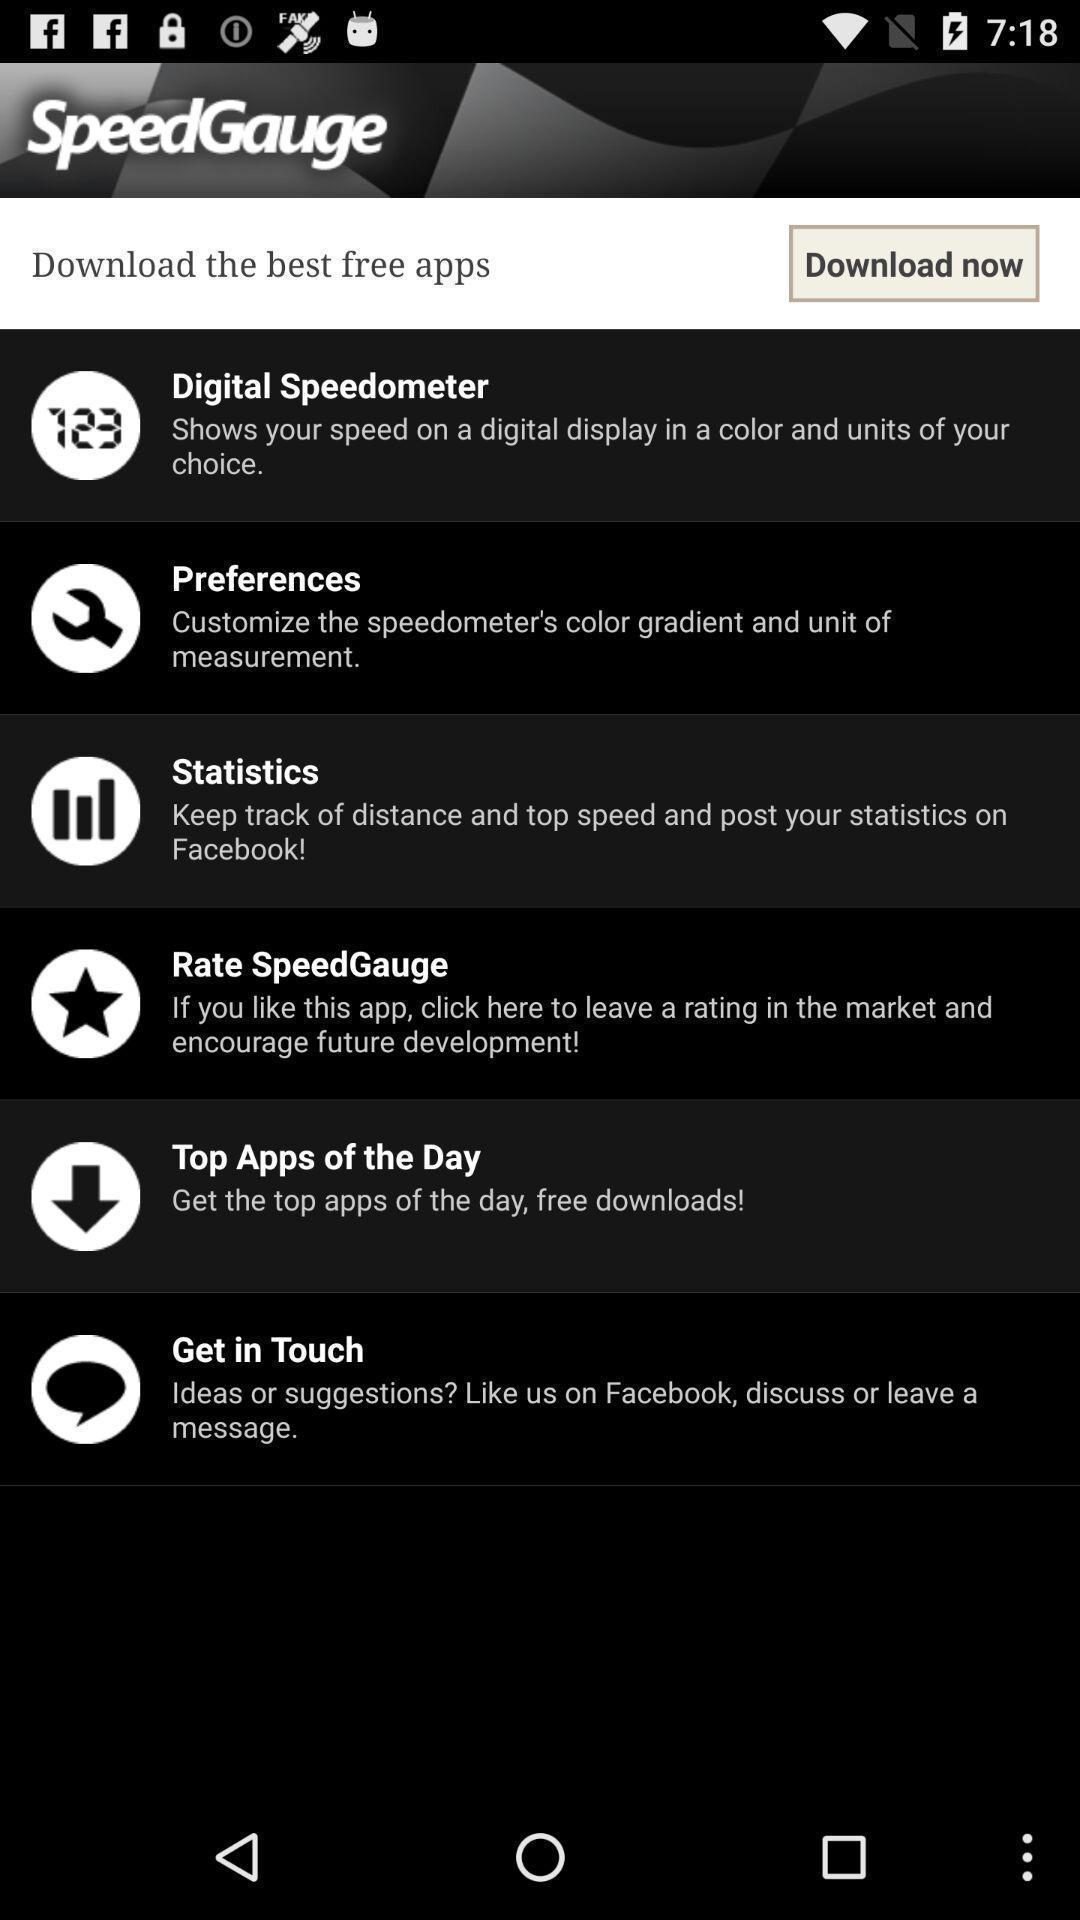What is the overall content of this screenshot? Page showing multiple options. 